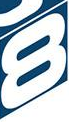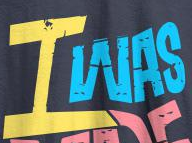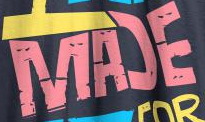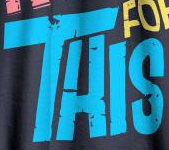What text appears in these images from left to right, separated by a semicolon? 8; IWAS; MAƆE; THIS 